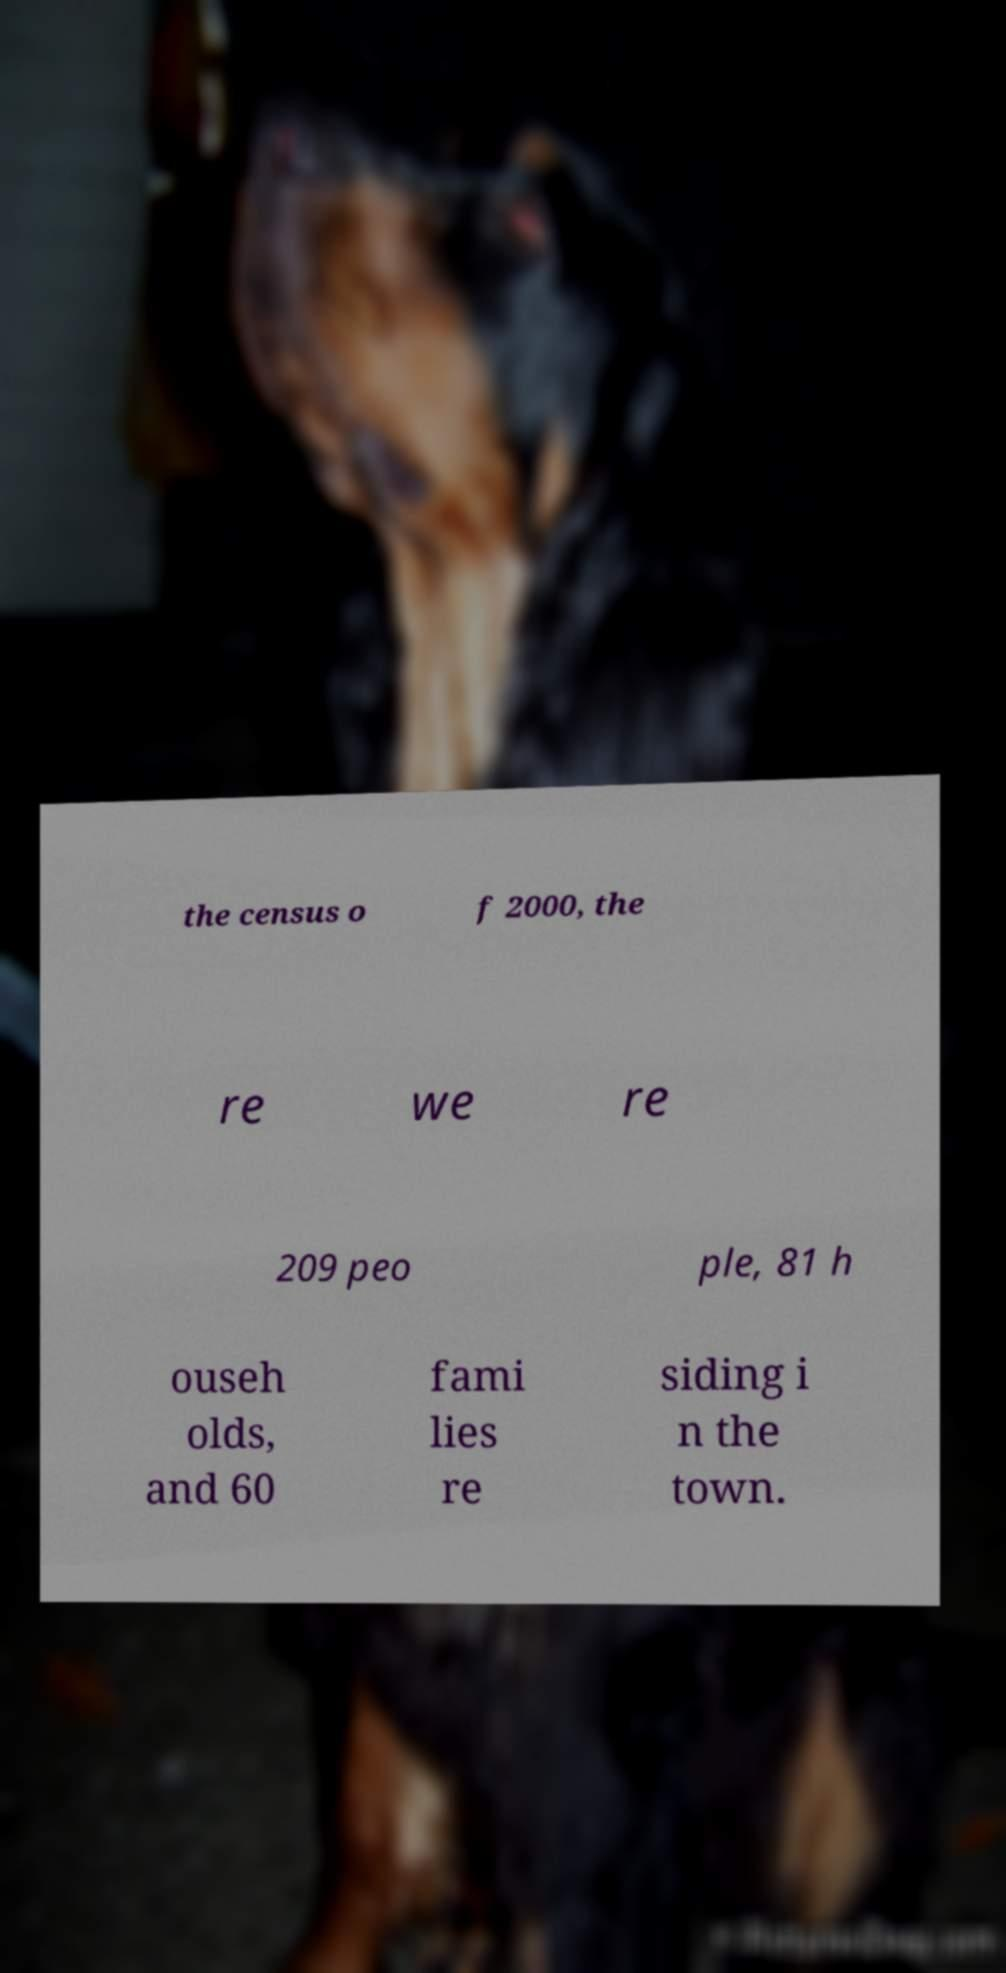I need the written content from this picture converted into text. Can you do that? the census o f 2000, the re we re 209 peo ple, 81 h ouseh olds, and 60 fami lies re siding i n the town. 